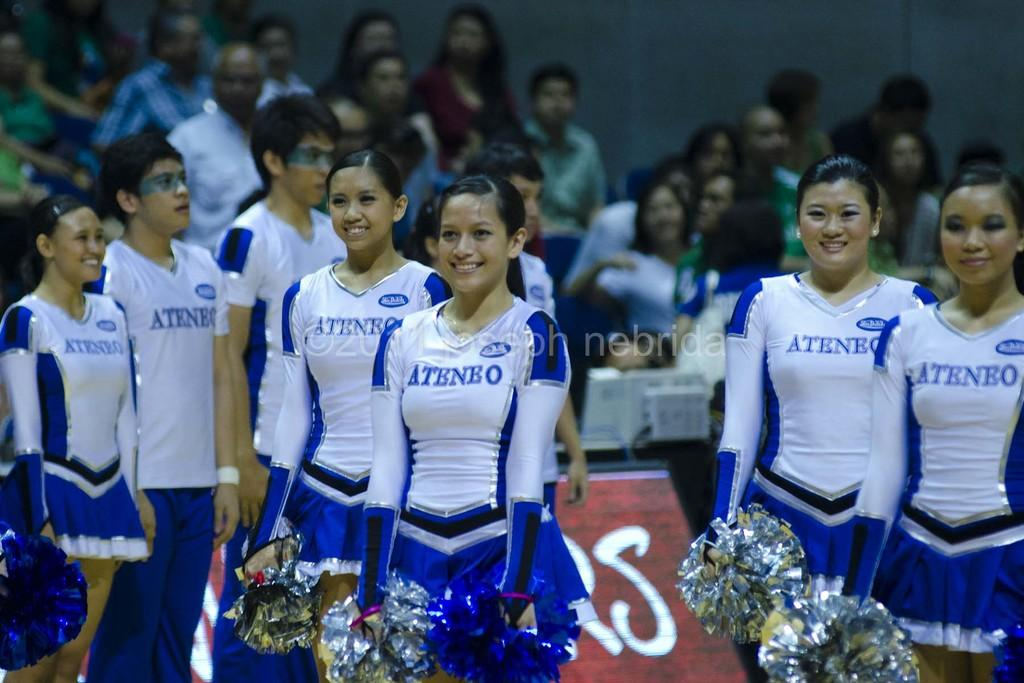Provide a one-sentence caption for the provided image. The Ateneo cheerleading team is dressed in blue and standing with their arms down while holidng their pom poms. 